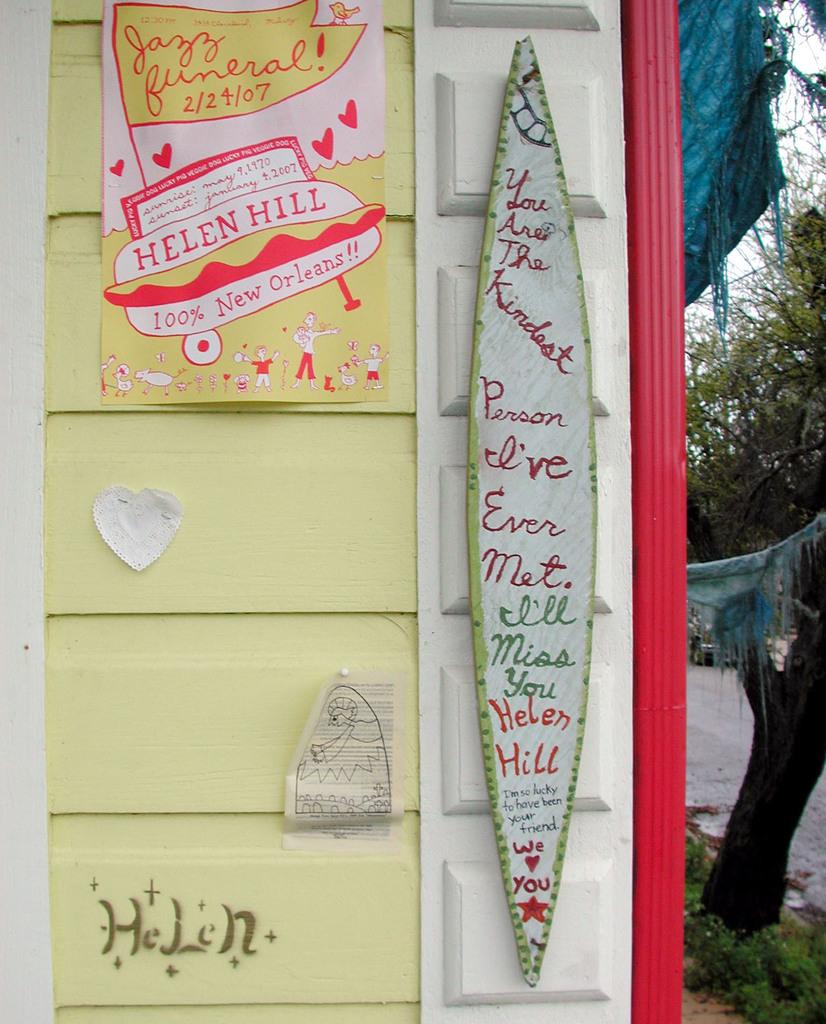What is on the wall in the image? There are papers and other things on the wall in the image. What can be seen on one side of the wall? There are trees on one side of the wall. What type of path is visible in the image? There is a path in the image. What is visible in the sky in the image? The sky is visible in the image. What type of bread can be seen in the image? There is no bread present in the image. Is the crook trying to steal the papers from the wall in the image? There is no crook or indication of theft in the image; it simply shows a wall with papers and other things. 